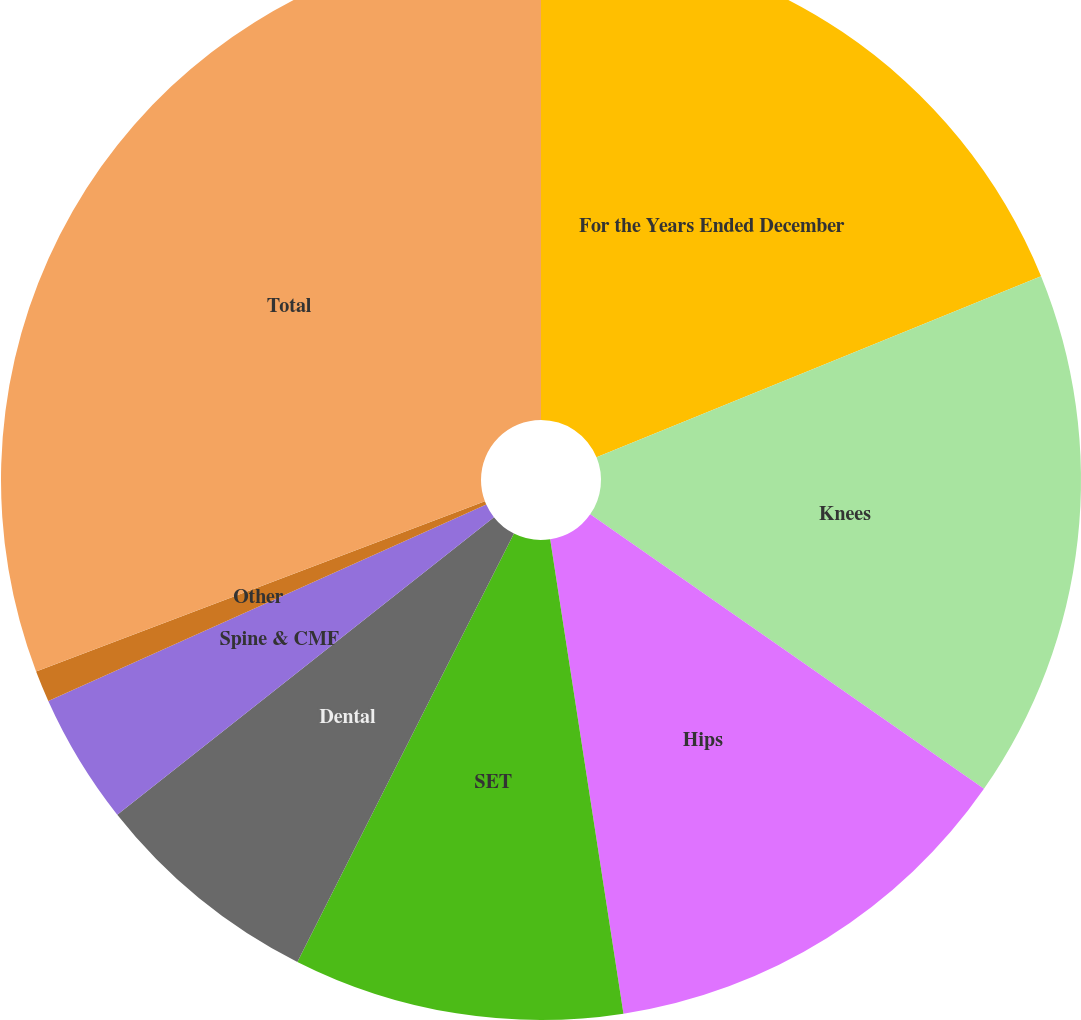<chart> <loc_0><loc_0><loc_500><loc_500><pie_chart><fcel>For the Years Ended December<fcel>Knees<fcel>Hips<fcel>SET<fcel>Dental<fcel>Spine & CMF<fcel>Other<fcel>Total<nl><fcel>18.84%<fcel>15.85%<fcel>12.87%<fcel>9.89%<fcel>6.91%<fcel>3.93%<fcel>0.94%<fcel>30.77%<nl></chart> 